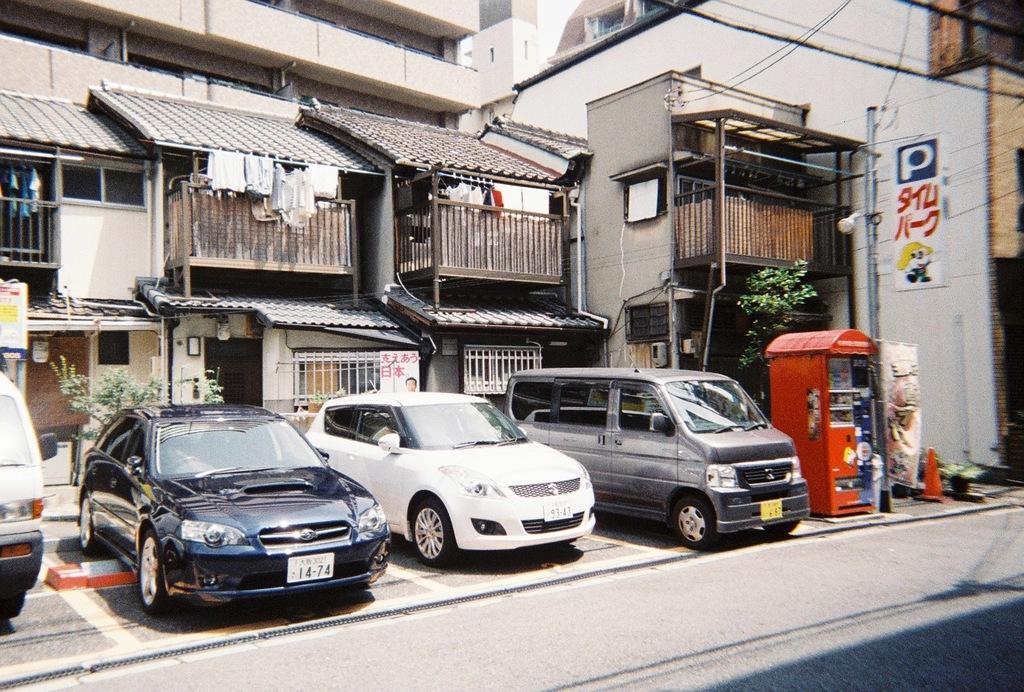Please provide a concise description of this image. In this picture we can see buildings, there are some vehicles in the front, on the right side there is a traffic cone, a pole, hoardings and a vending machine, there is a plant on the left side, we can see some clothes in the middle. 